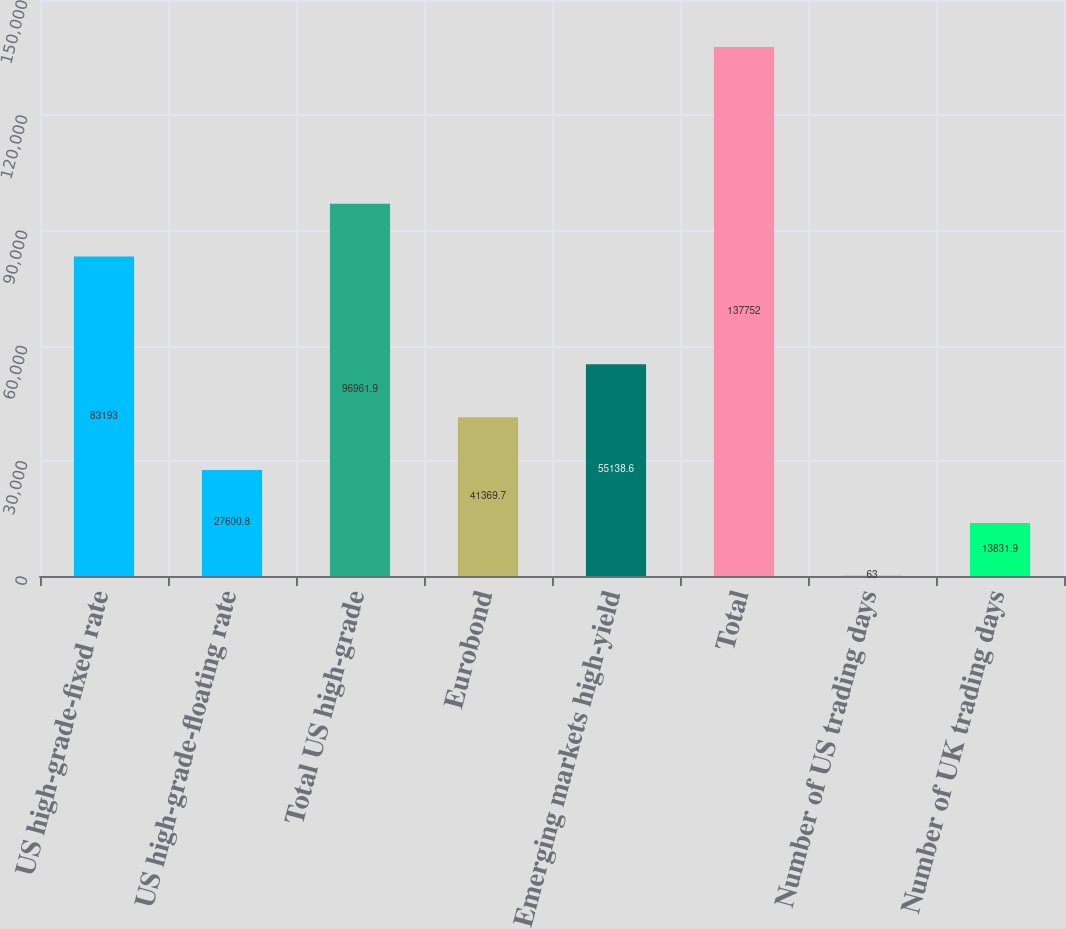Convert chart to OTSL. <chart><loc_0><loc_0><loc_500><loc_500><bar_chart><fcel>US high-grade-fixed rate<fcel>US high-grade-floating rate<fcel>Total US high-grade<fcel>Eurobond<fcel>Emerging markets high-yield<fcel>Total<fcel>Number of US trading days<fcel>Number of UK trading days<nl><fcel>83193<fcel>27600.8<fcel>96961.9<fcel>41369.7<fcel>55138.6<fcel>137752<fcel>63<fcel>13831.9<nl></chart> 